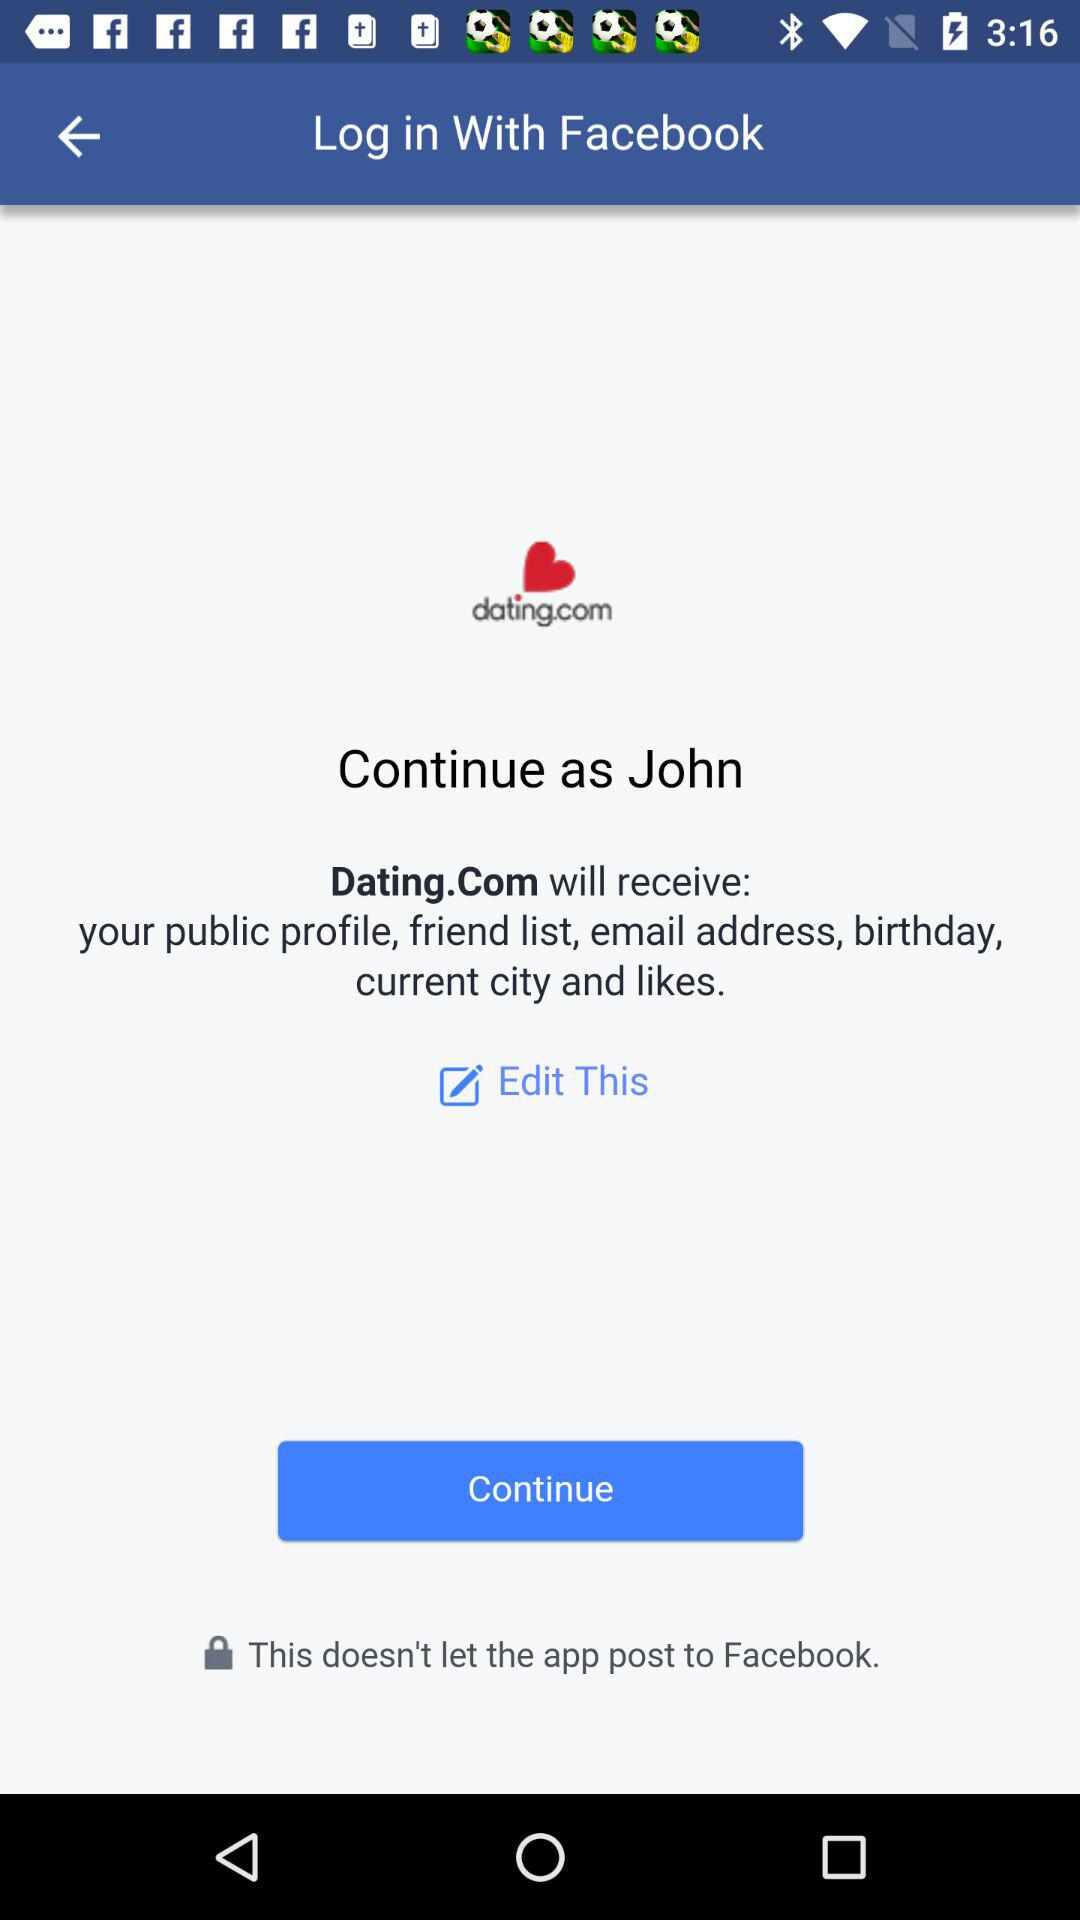What application will receive the public profile, friend list, email address, birthday, current city and likes? The application "Dating.Com" will receive the public profile, friend list, email address, birthday, current city and likes. 